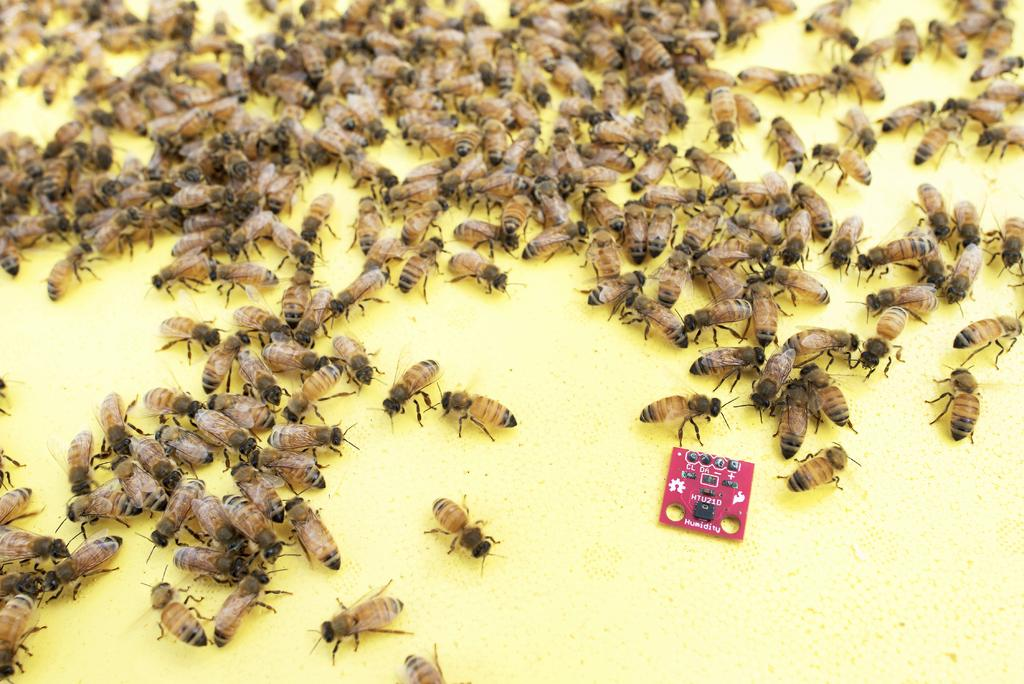What type of insects are present in the image? There are honey bees in the image. What are the honey bees doing in the image? The honey bees are sitting on food. What is the color of the food that the honey bees are sitting on? The food is yellow in color. What type of pest can be seen crawling on the fish in the image? There is no fish or crawling pest present in the image; it features honey bees sitting on yellow food. 